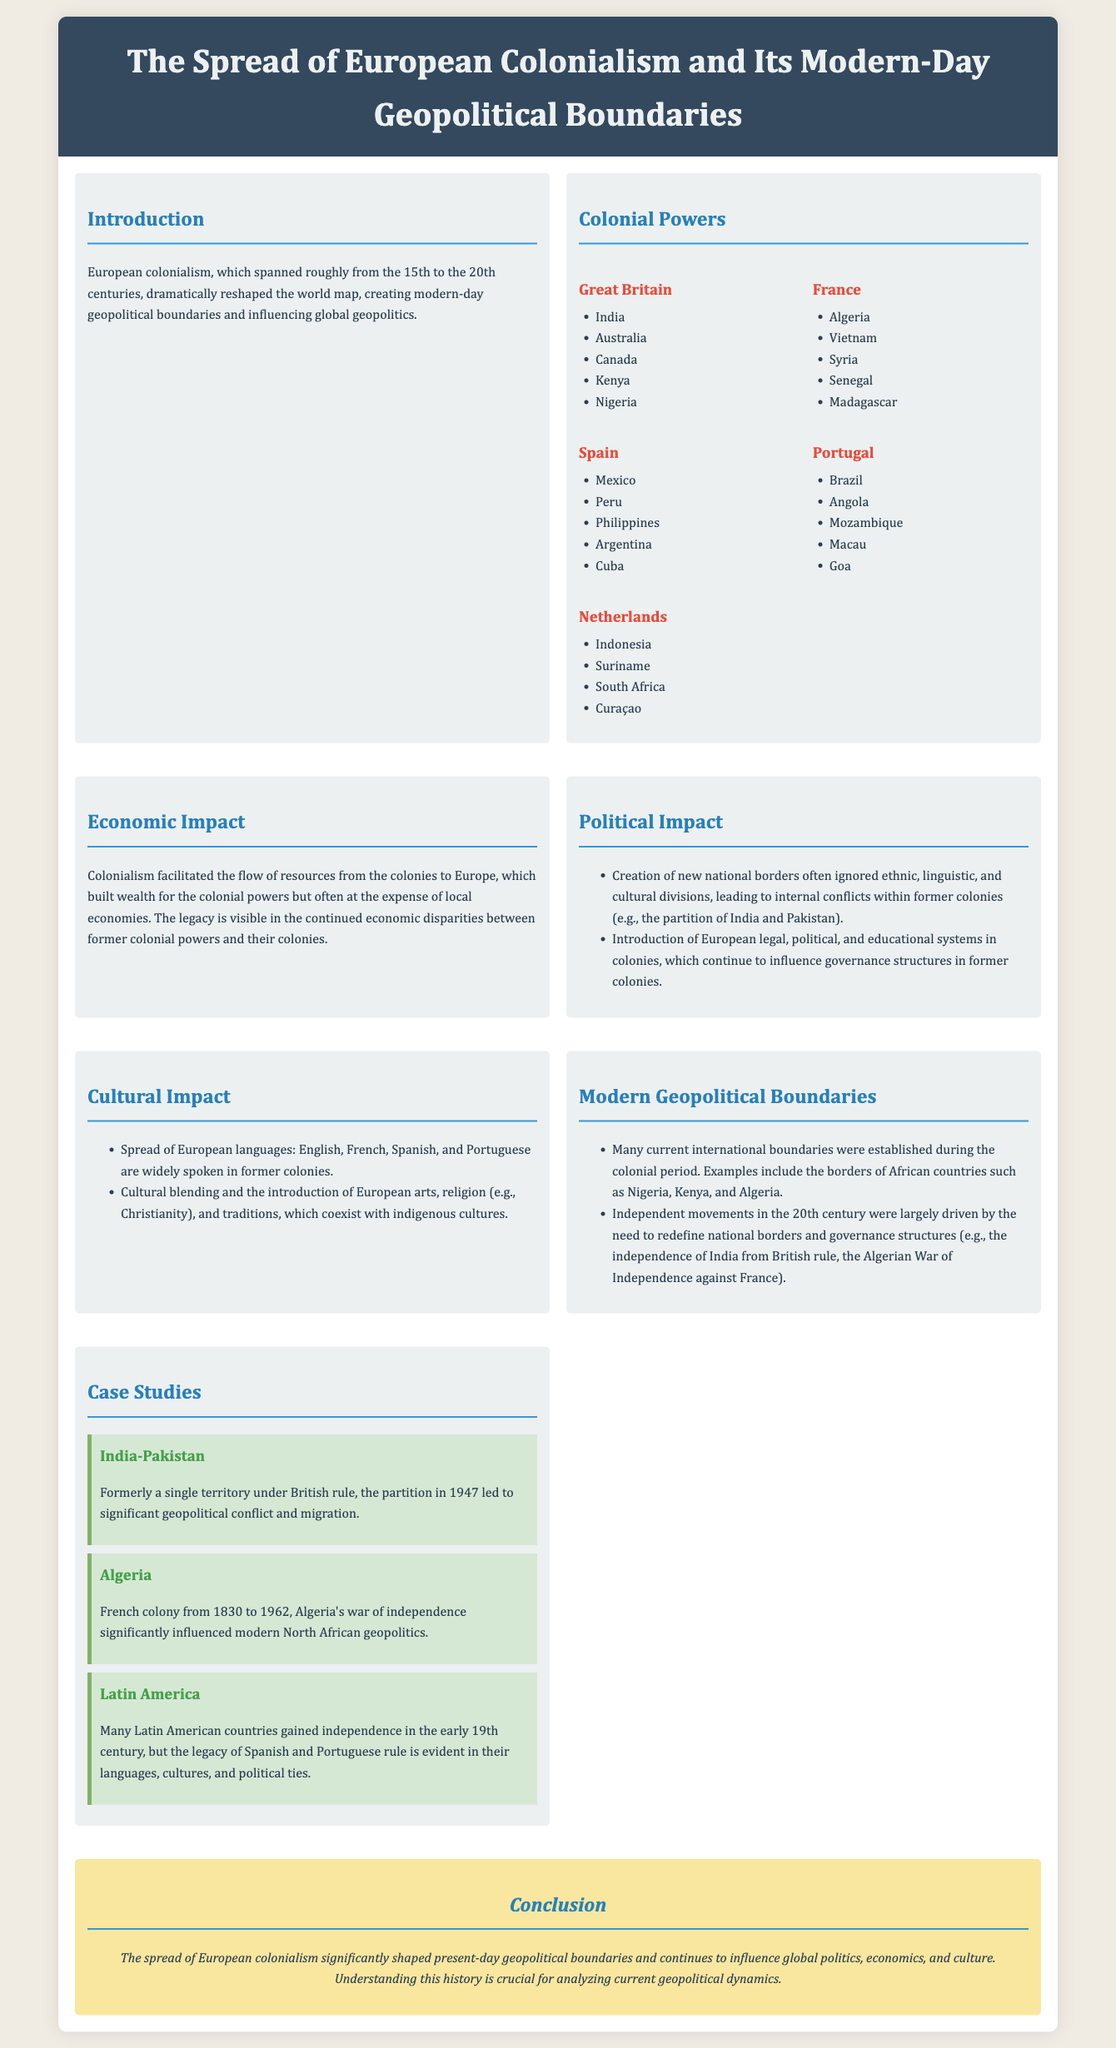What years did European colonialism span? The document states that European colonialism spanned from the 15th to the 20th centuries.
Answer: 15th to 20th centuries Which country is listed as a former colony of Great Britain? The document lists several countries under Great Britain, including India, Australia, Canada, Kenya, and Nigeria.
Answer: India What major impact did colonialism have on local economies? According to the document, colonialism facilitated the flow of resources to Europe, often at the expense of local economies, resulting in economic disparities.
Answer: Economic disparities What was a significant political consequence of colonial borders? The document mentions that many national borders created during colonialism ignored ethnic and cultural divisions, leading to internal conflicts.
Answer: Internal conflicts What colonial power ruled Algeria? The document states that Algeria was a French colony from 1830 to 1962.
Answer: French How did European languages spread to former colonies? The document notes that the spread of European languages occurred through colonization, with English, French, Spanish, and Portuguese widely spoken in former colonies.
Answer: Colonization Which two countries were involved in the 1947 partition? The document references the partition in 1947 between British India and Pakistan.
Answer: British India and Pakistan What does the case study on Latin America illustrate? The Latin America case study highlights that many countries gained independence from Spanish and Portuguese rule, leaving a legacy in languages and cultures.
Answer: Independence from Spanish and Portuguese rule What is the conclusion drawn about the impact of colonialism? The conclusion states that European colonialism significantly shaped present-day geopolitical boundaries and continues influencing global politics and culture.
Answer: Shaped present-day geopolitical boundaries 